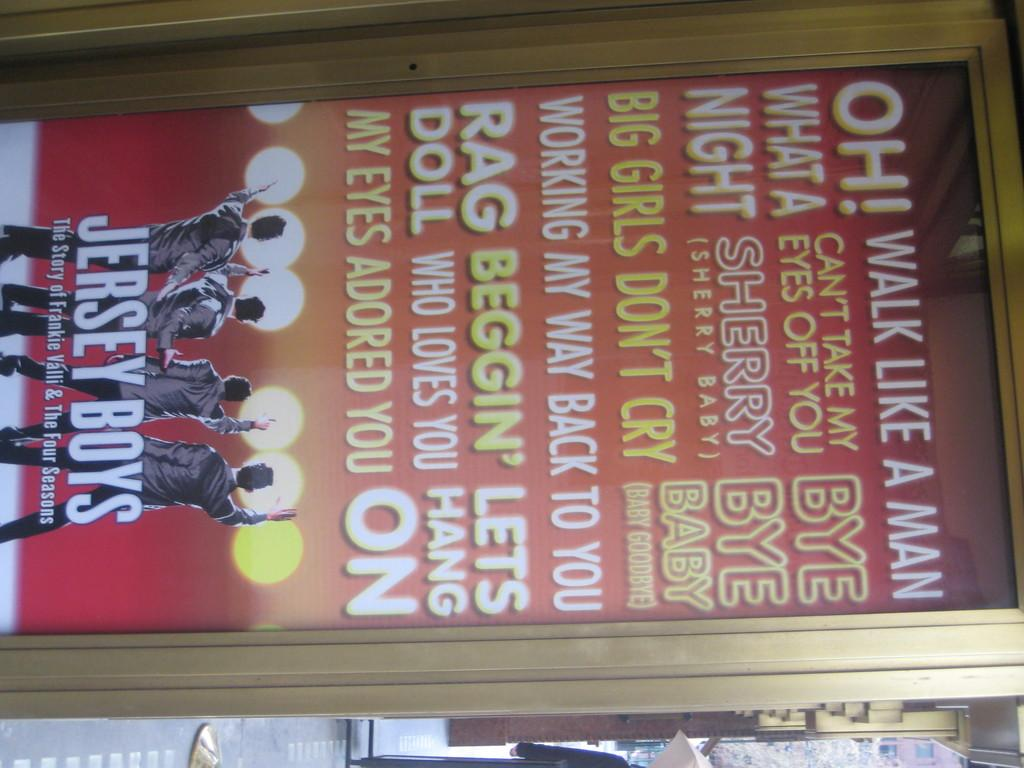Provide a one-sentence caption for the provided image. A framed poster for the Jersey Boys movie, many songs listed on the poster like Rag Doll and Big girls don't cry. 